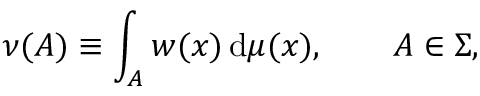<formula> <loc_0><loc_0><loc_500><loc_500>\nu ( A ) \equiv \int _ { A } w ( x ) \, d \mu ( x ) , \quad A \in \Sigma ,</formula> 